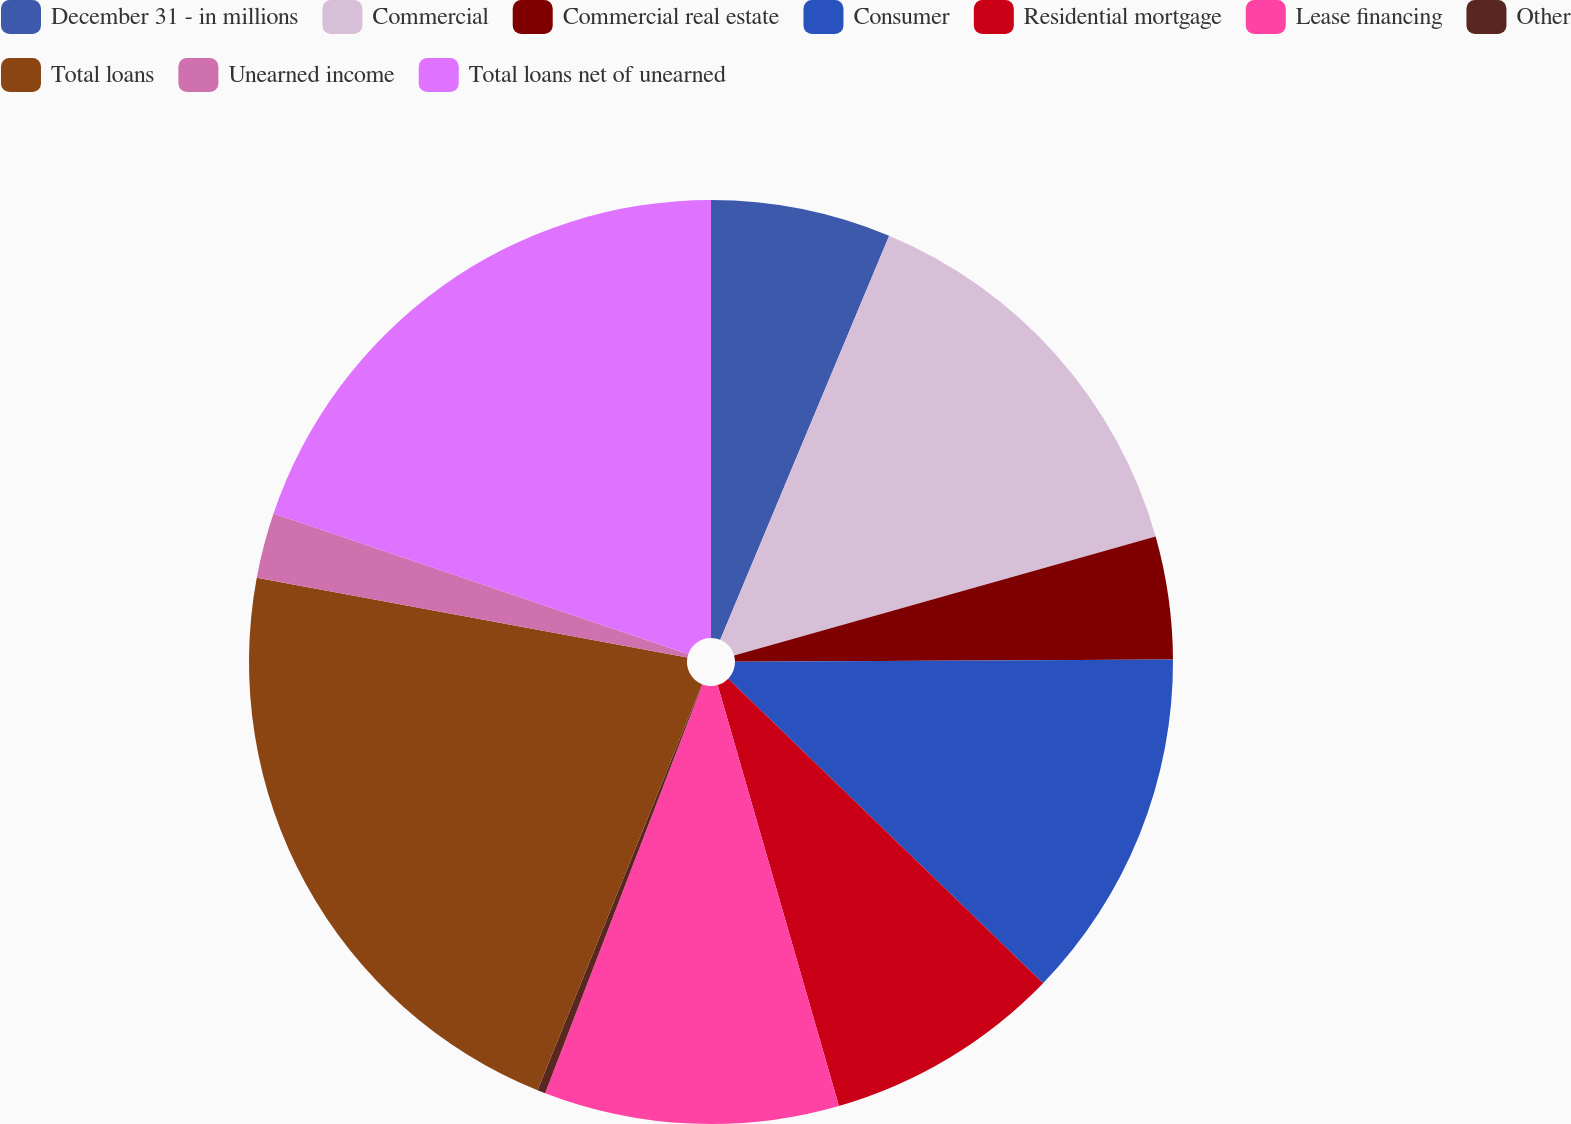<chart> <loc_0><loc_0><loc_500><loc_500><pie_chart><fcel>December 31 - in millions<fcel>Commercial<fcel>Commercial real estate<fcel>Consumer<fcel>Residential mortgage<fcel>Lease financing<fcel>Other<fcel>Total loans<fcel>Unearned income<fcel>Total loans net of unearned<nl><fcel>6.3%<fcel>14.32%<fcel>4.29%<fcel>12.32%<fcel>8.3%<fcel>10.31%<fcel>0.28%<fcel>21.79%<fcel>2.29%<fcel>19.79%<nl></chart> 